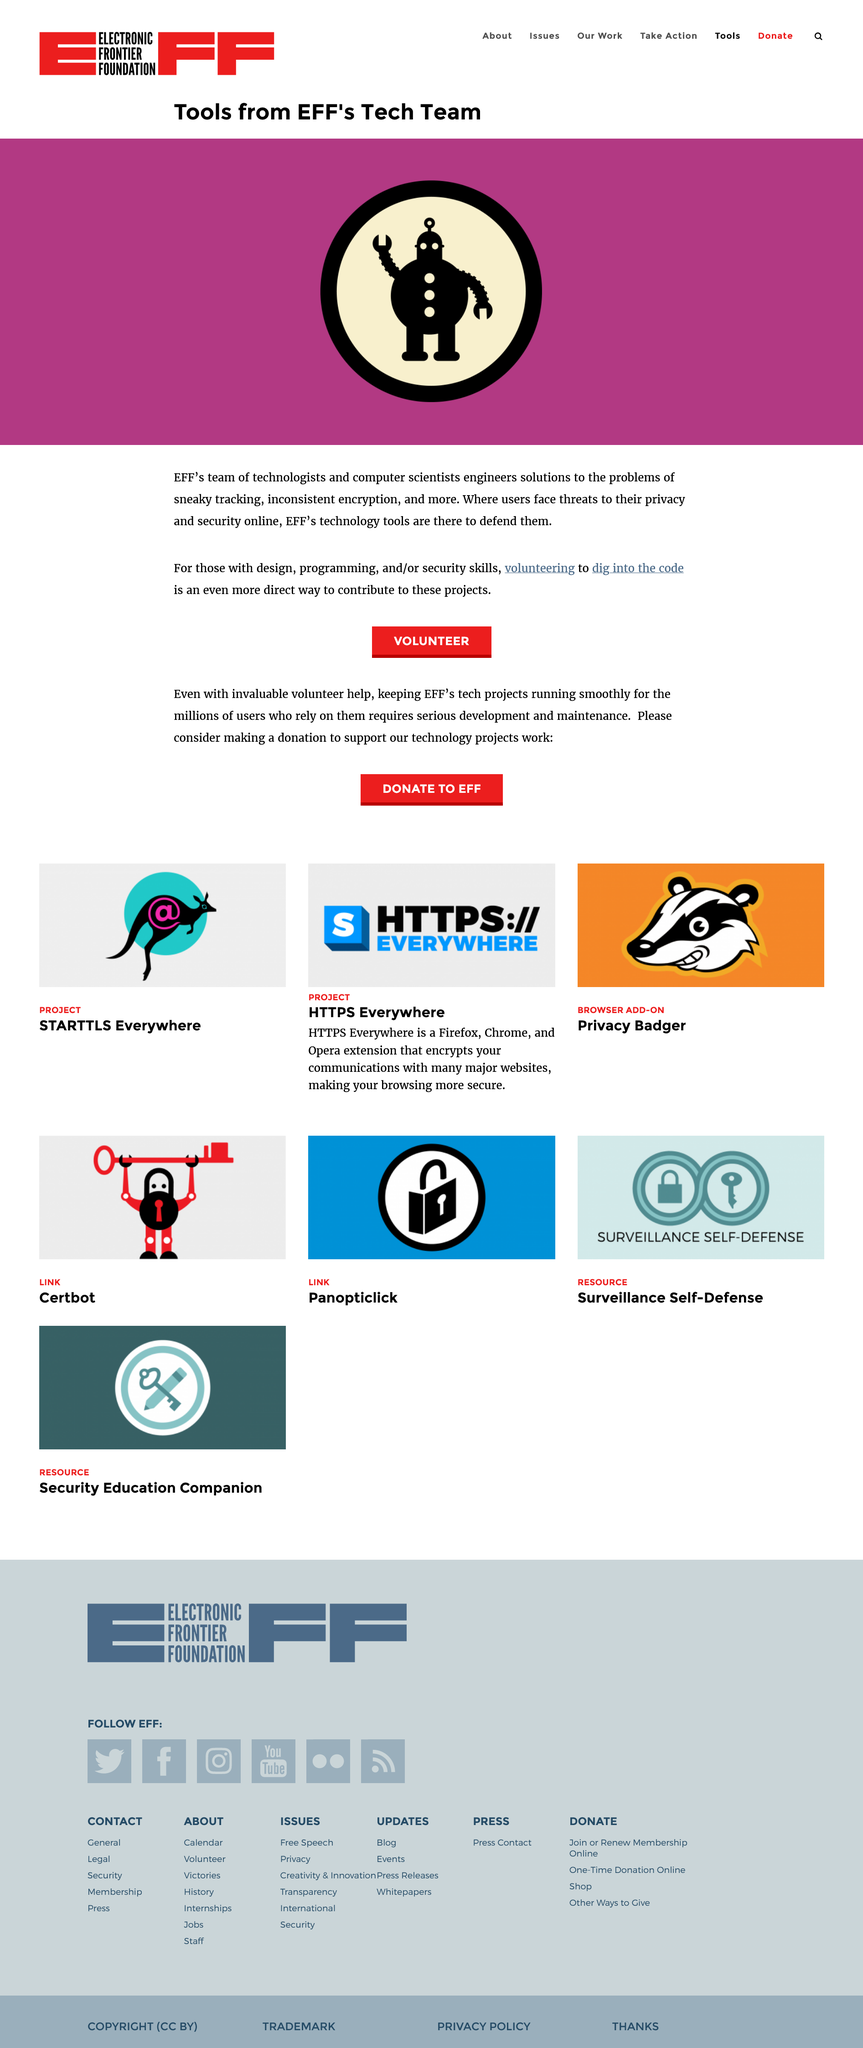List a handful of essential elements in this visual. EFF's team of technologists engineers solutions to sneaky tracking, inconsistent encryption, and other technological issues that threaten the privacy and security of individuals. EFF's tech team consists of technologists and computer scientists who work to advance the organization's mission of defending civil liberties in the digital world. People with programming skills can aid in the fight against misinformation by volunteering to review and improve the code used in various systems and platforms. 